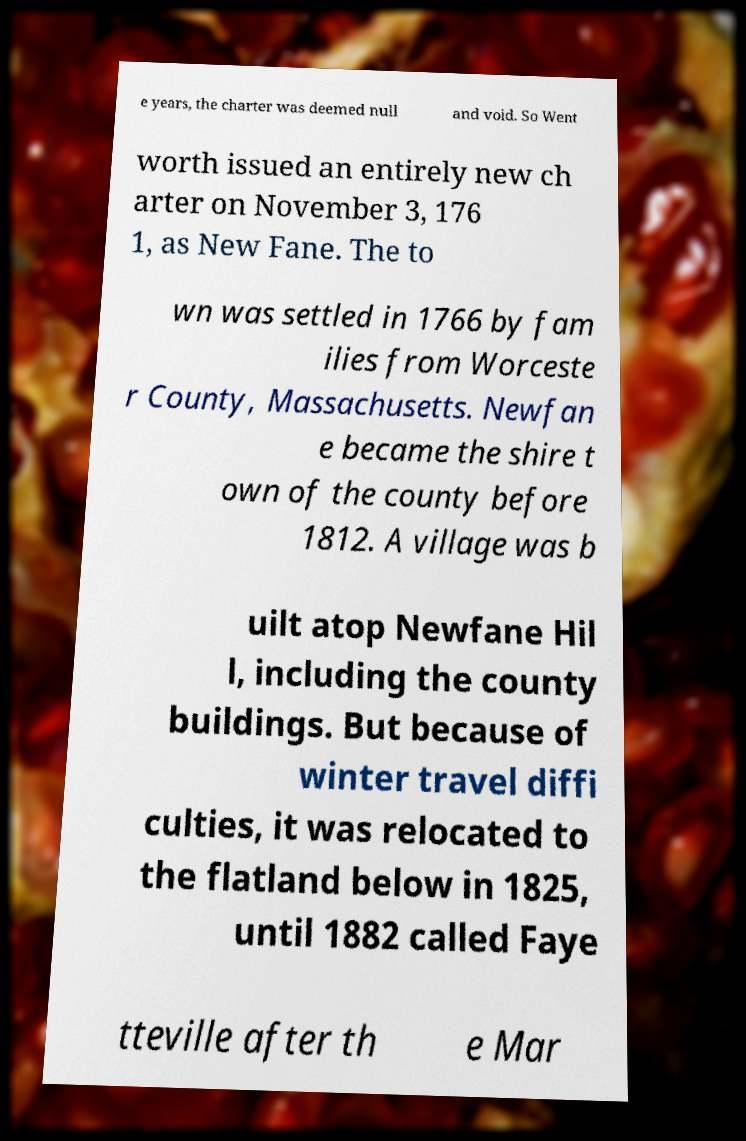Please read and relay the text visible in this image. What does it say? e years, the charter was deemed null and void. So Went worth issued an entirely new ch arter on November 3, 176 1, as New Fane. The to wn was settled in 1766 by fam ilies from Worceste r County, Massachusetts. Newfan e became the shire t own of the county before 1812. A village was b uilt atop Newfane Hil l, including the county buildings. But because of winter travel diffi culties, it was relocated to the flatland below in 1825, until 1882 called Faye tteville after th e Mar 